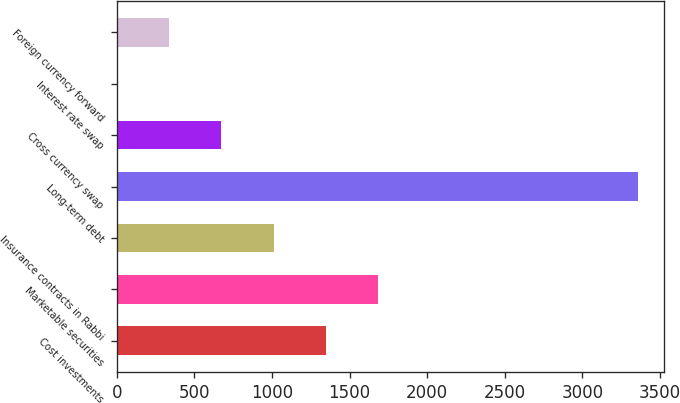<chart> <loc_0><loc_0><loc_500><loc_500><bar_chart><fcel>Cost investments<fcel>Marketable securities<fcel>Insurance contracts in Rabbi<fcel>Long-term debt<fcel>Cross currency swap<fcel>Interest rate swap<fcel>Foreign currency forward<nl><fcel>1345.4<fcel>1681<fcel>1009.8<fcel>3359<fcel>674.2<fcel>3<fcel>338.6<nl></chart> 